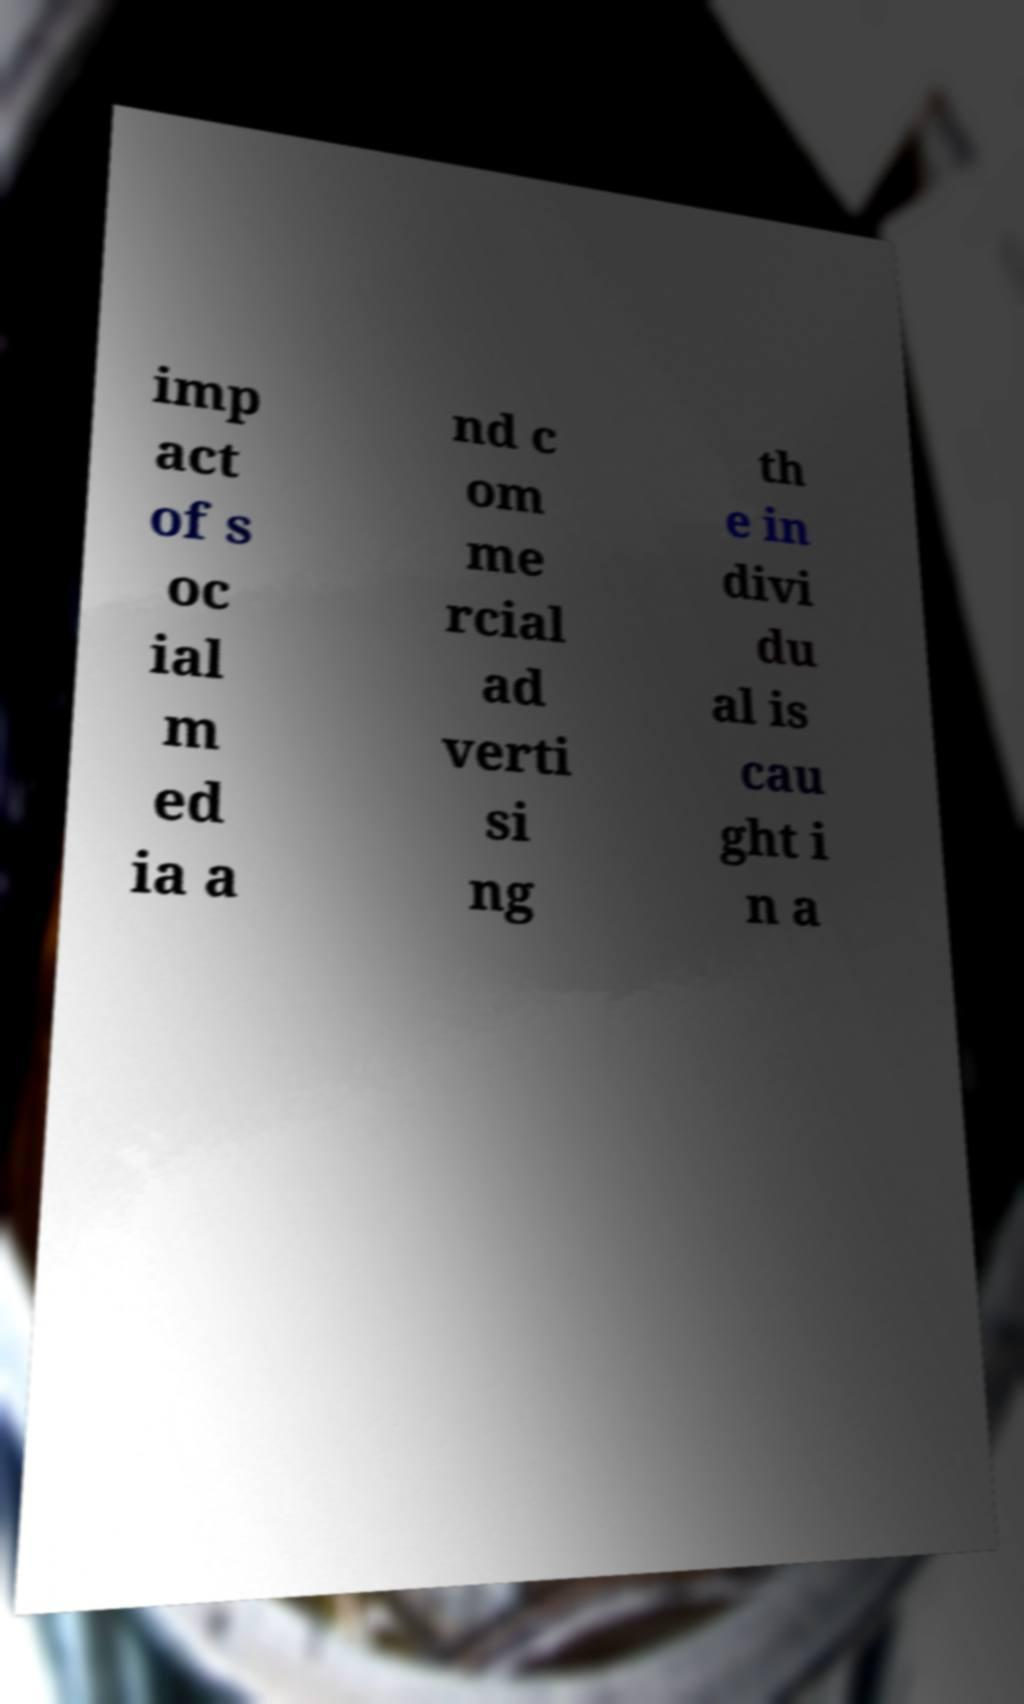Please read and relay the text visible in this image. What does it say? imp act of s oc ial m ed ia a nd c om me rcial ad verti si ng th e in divi du al is cau ght i n a 